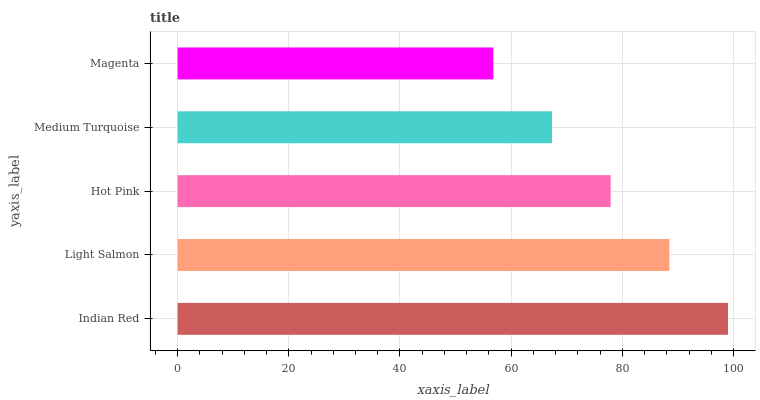Is Magenta the minimum?
Answer yes or no. Yes. Is Indian Red the maximum?
Answer yes or no. Yes. Is Light Salmon the minimum?
Answer yes or no. No. Is Light Salmon the maximum?
Answer yes or no. No. Is Indian Red greater than Light Salmon?
Answer yes or no. Yes. Is Light Salmon less than Indian Red?
Answer yes or no. Yes. Is Light Salmon greater than Indian Red?
Answer yes or no. No. Is Indian Red less than Light Salmon?
Answer yes or no. No. Is Hot Pink the high median?
Answer yes or no. Yes. Is Hot Pink the low median?
Answer yes or no. Yes. Is Light Salmon the high median?
Answer yes or no. No. Is Light Salmon the low median?
Answer yes or no. No. 